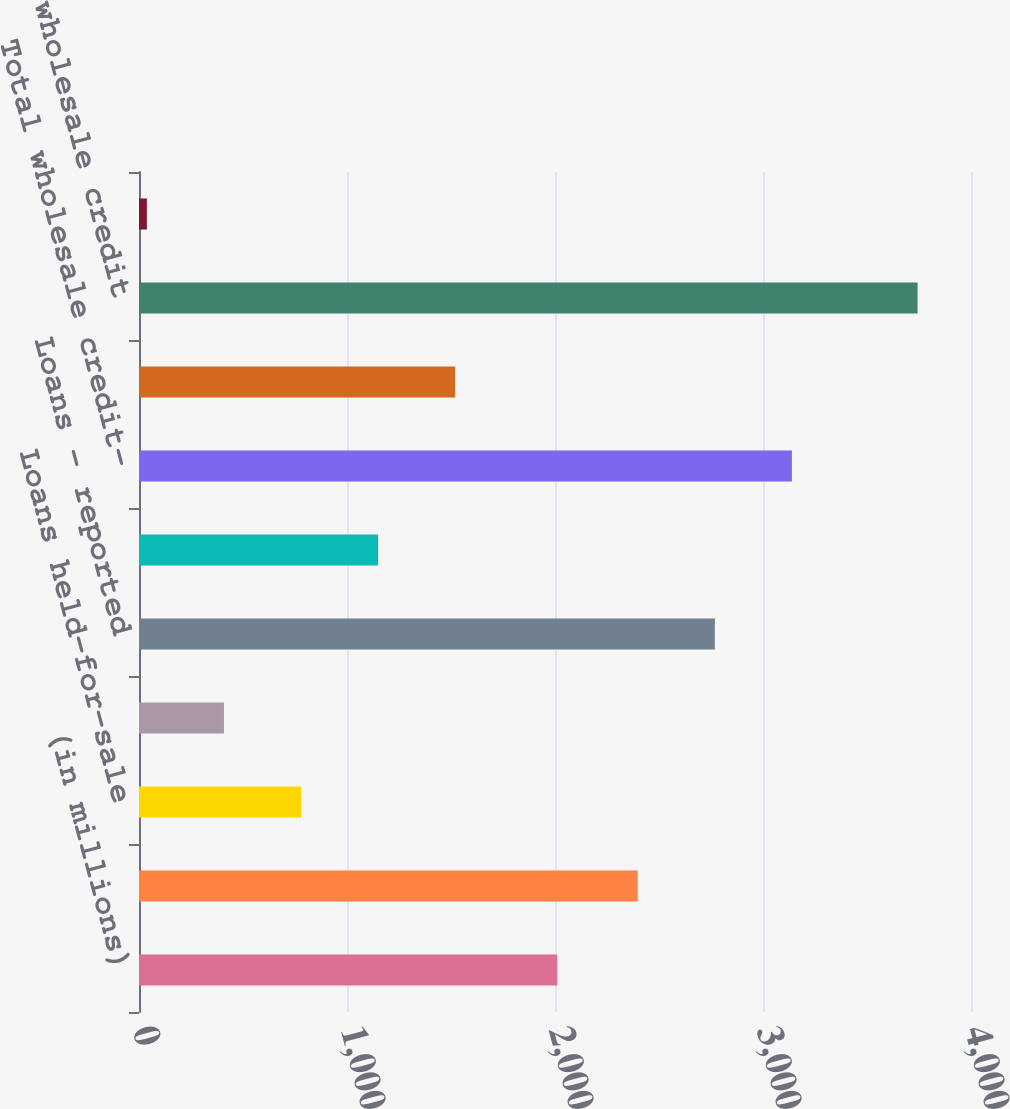<chart> <loc_0><loc_0><loc_500><loc_500><bar_chart><fcel>(in millions)<fcel>Loans retained<fcel>Loans held-for-sale<fcel>Loans at fair value<fcel>Loans - reported<fcel>Derivative receivables<fcel>Total wholesale credit-<fcel>Lending-related commitments<fcel>Total wholesale credit<fcel>Credit Portfolio Management<nl><fcel>2011<fcel>2398<fcel>779<fcel>408.5<fcel>2768.5<fcel>1149.5<fcel>3139<fcel>1520<fcel>3743<fcel>38<nl></chart> 